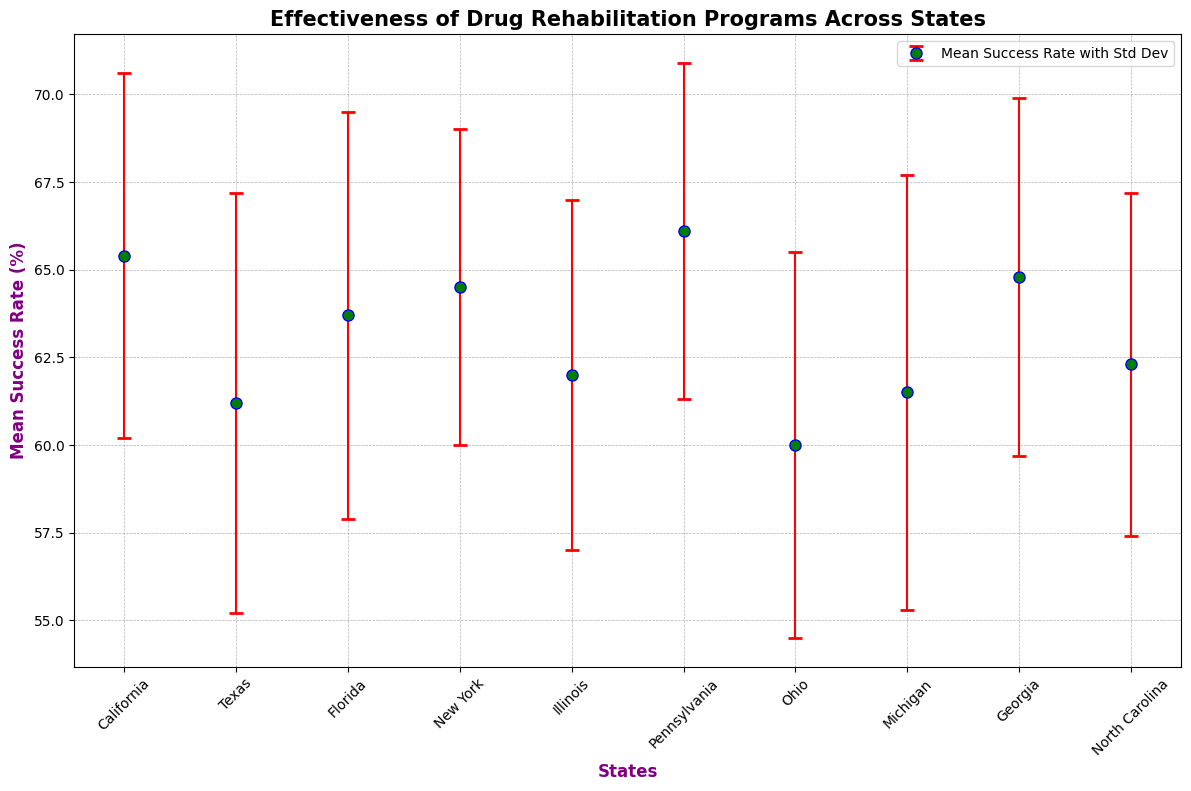What is the state with the highest mean success rate for drug rehabilitation programs? To determine the state with the highest mean success rate, examine the mean success rates for each state and identify the maximum value. Pennsylvania has the highest mean success rate of 66.1%
Answer: Pennsylvania What are the two states with the lowest and highest standard deviations in success rates? Look at the standard deviations listed alongside each state and identify the minimum and maximum values. New York has the lowest standard deviation at 4.5, while Michigan has the highest at 6.2.
Answer: New York and Michigan Which state has a mean success rate closest to the average of all mean success rates? First, calculate the average of all mean success rates: (65.4 + 61.2 + 63.7 + 64.5 + 62.0 + 66.1 + 60.0 + 61.5 + 64.8 + 62.3) / 10 = 63.15. Then, determine the state whose mean success rate is closest to this value. Florida's mean success rate (63.7) is closest to 63.15.
Answer: Florida How does the mean success rate of California compare to Texas? Look at the mean success rates for California (65.4) and Texas (61.2). California's mean success rate is higher.
Answer: California has a higher mean success rate than Texas Which states have a mean success rate greater than 64%? Identify the states with mean success rates above 64. These states are California (65.4), Florida (63.7), New York (64.5), and Pennsylvania (66.1), and Georgia (64.8).
Answer: California, New York, Pennsylvania, Georgia What's the difference in mean success rates between Ohio and Michigan? Subtract the mean success rate of Ohio (60.0) from Michigan (61.5): 61.5 - 60.0 = 1.5.
Answer: 1.5 What is the mean success rate of the state with the smallest sample size? Look at the sample sizes and find the smallest one: Pennsylvania with 70. The mean success rate for Pennsylvania is 66.1.
Answer: 66.1 What is the sum of the mean success rates for North Carolina and New York? Add the mean success rates for North Carolina (62.3) and New York (64.5): 62.3 + 64.5 = 126.8.
Answer: 126.8 Which state has a similar mean success rate to Illinois, and what is that rate? Compare the mean success rate of Illinois (62.0) with those of other states and find the closest match. North Carolina has a close mean success rate (62.3).
Answer: North Carolina has a similar rate 